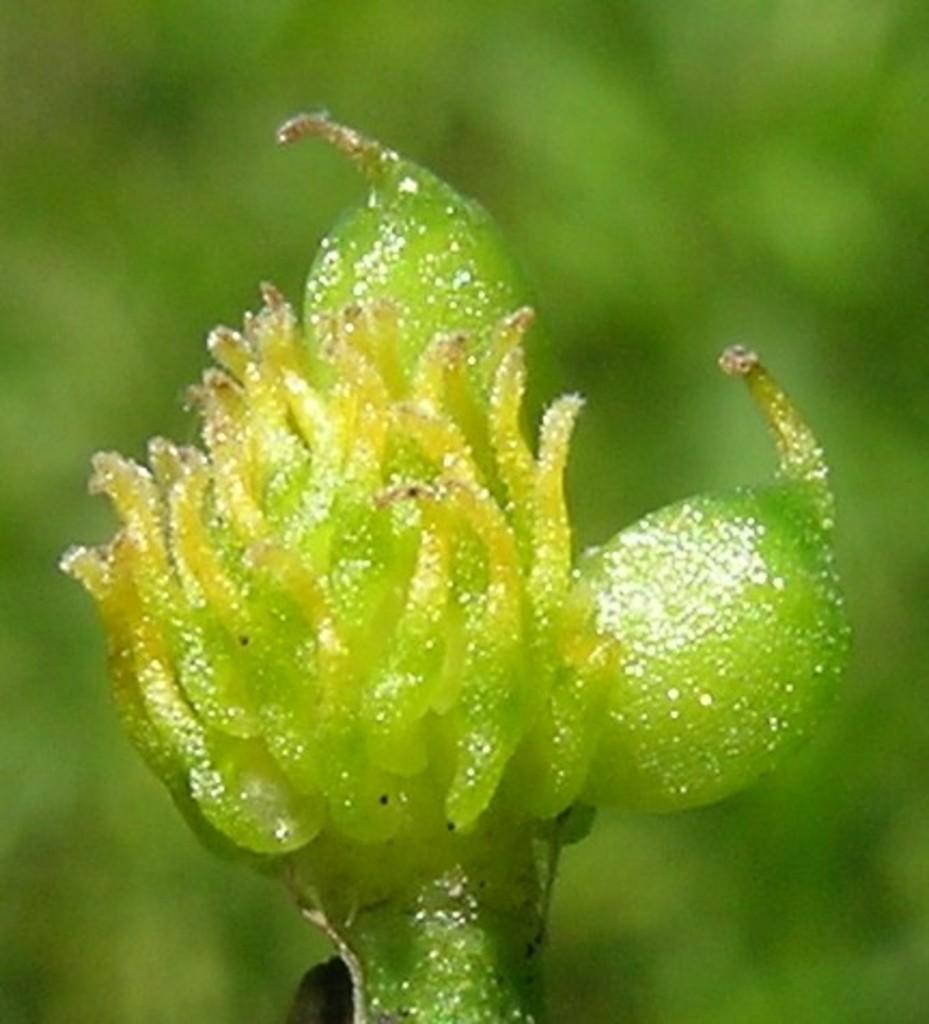In one or two sentences, can you explain what this image depicts? In this picture there is an object which is in green color. 